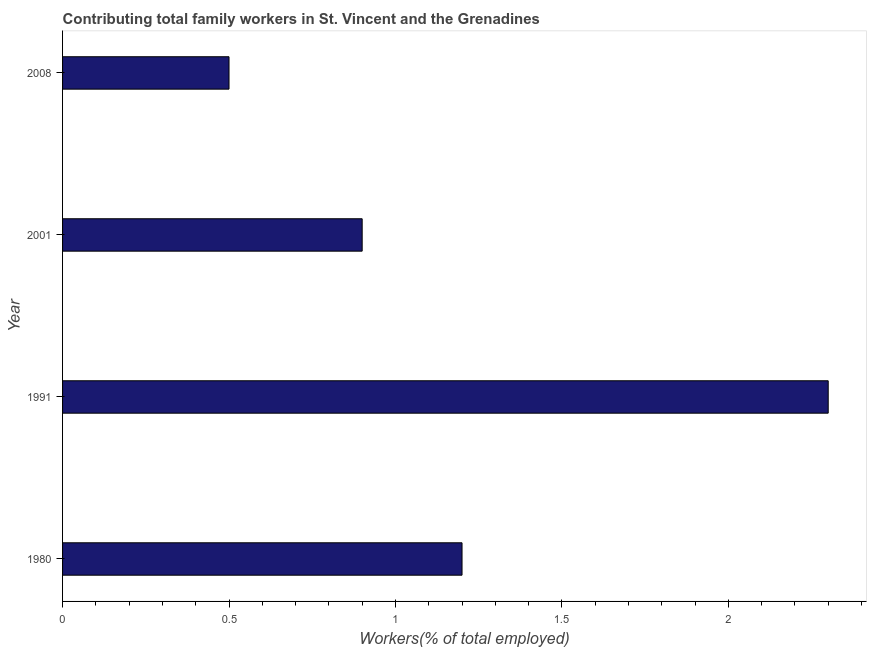Does the graph contain any zero values?
Offer a very short reply. No. Does the graph contain grids?
Ensure brevity in your answer.  No. What is the title of the graph?
Your answer should be compact. Contributing total family workers in St. Vincent and the Grenadines. What is the label or title of the X-axis?
Ensure brevity in your answer.  Workers(% of total employed). What is the contributing family workers in 2001?
Ensure brevity in your answer.  0.9. Across all years, what is the maximum contributing family workers?
Make the answer very short. 2.3. Across all years, what is the minimum contributing family workers?
Keep it short and to the point. 0.5. In which year was the contributing family workers maximum?
Keep it short and to the point. 1991. What is the sum of the contributing family workers?
Offer a very short reply. 4.9. What is the difference between the contributing family workers in 1980 and 2001?
Offer a very short reply. 0.3. What is the average contributing family workers per year?
Offer a very short reply. 1.23. What is the median contributing family workers?
Provide a short and direct response. 1.05. Do a majority of the years between 2008 and 1980 (inclusive) have contributing family workers greater than 2.2 %?
Your answer should be very brief. Yes. What is the ratio of the contributing family workers in 1991 to that in 2008?
Your answer should be compact. 4.6. Is the contributing family workers in 1980 less than that in 1991?
Keep it short and to the point. Yes. What is the difference between the highest and the second highest contributing family workers?
Your answer should be very brief. 1.1. In how many years, is the contributing family workers greater than the average contributing family workers taken over all years?
Offer a terse response. 1. What is the difference between two consecutive major ticks on the X-axis?
Provide a short and direct response. 0.5. Are the values on the major ticks of X-axis written in scientific E-notation?
Make the answer very short. No. What is the Workers(% of total employed) in 1980?
Offer a terse response. 1.2. What is the Workers(% of total employed) in 1991?
Ensure brevity in your answer.  2.3. What is the Workers(% of total employed) of 2001?
Keep it short and to the point. 0.9. What is the difference between the Workers(% of total employed) in 1980 and 2001?
Make the answer very short. 0.3. What is the difference between the Workers(% of total employed) in 1980 and 2008?
Offer a very short reply. 0.7. What is the difference between the Workers(% of total employed) in 1991 and 2001?
Give a very brief answer. 1.4. What is the ratio of the Workers(% of total employed) in 1980 to that in 1991?
Offer a very short reply. 0.52. What is the ratio of the Workers(% of total employed) in 1980 to that in 2001?
Your answer should be compact. 1.33. What is the ratio of the Workers(% of total employed) in 1991 to that in 2001?
Keep it short and to the point. 2.56. What is the ratio of the Workers(% of total employed) in 1991 to that in 2008?
Offer a very short reply. 4.6. What is the ratio of the Workers(% of total employed) in 2001 to that in 2008?
Keep it short and to the point. 1.8. 